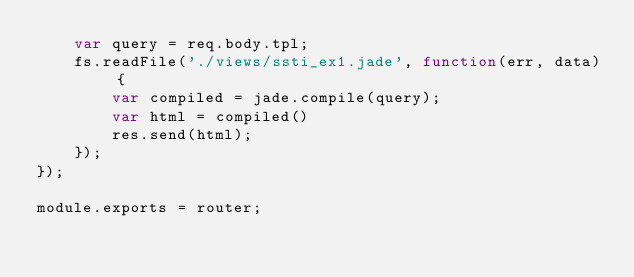<code> <loc_0><loc_0><loc_500><loc_500><_JavaScript_>    var query = req.body.tpl;
    fs.readFile('./views/ssti_ex1.jade', function(err, data) {
        var compiled = jade.compile(query);
        var html = compiled()
        res.send(html);
    });
});

module.exports = router;
</code> 